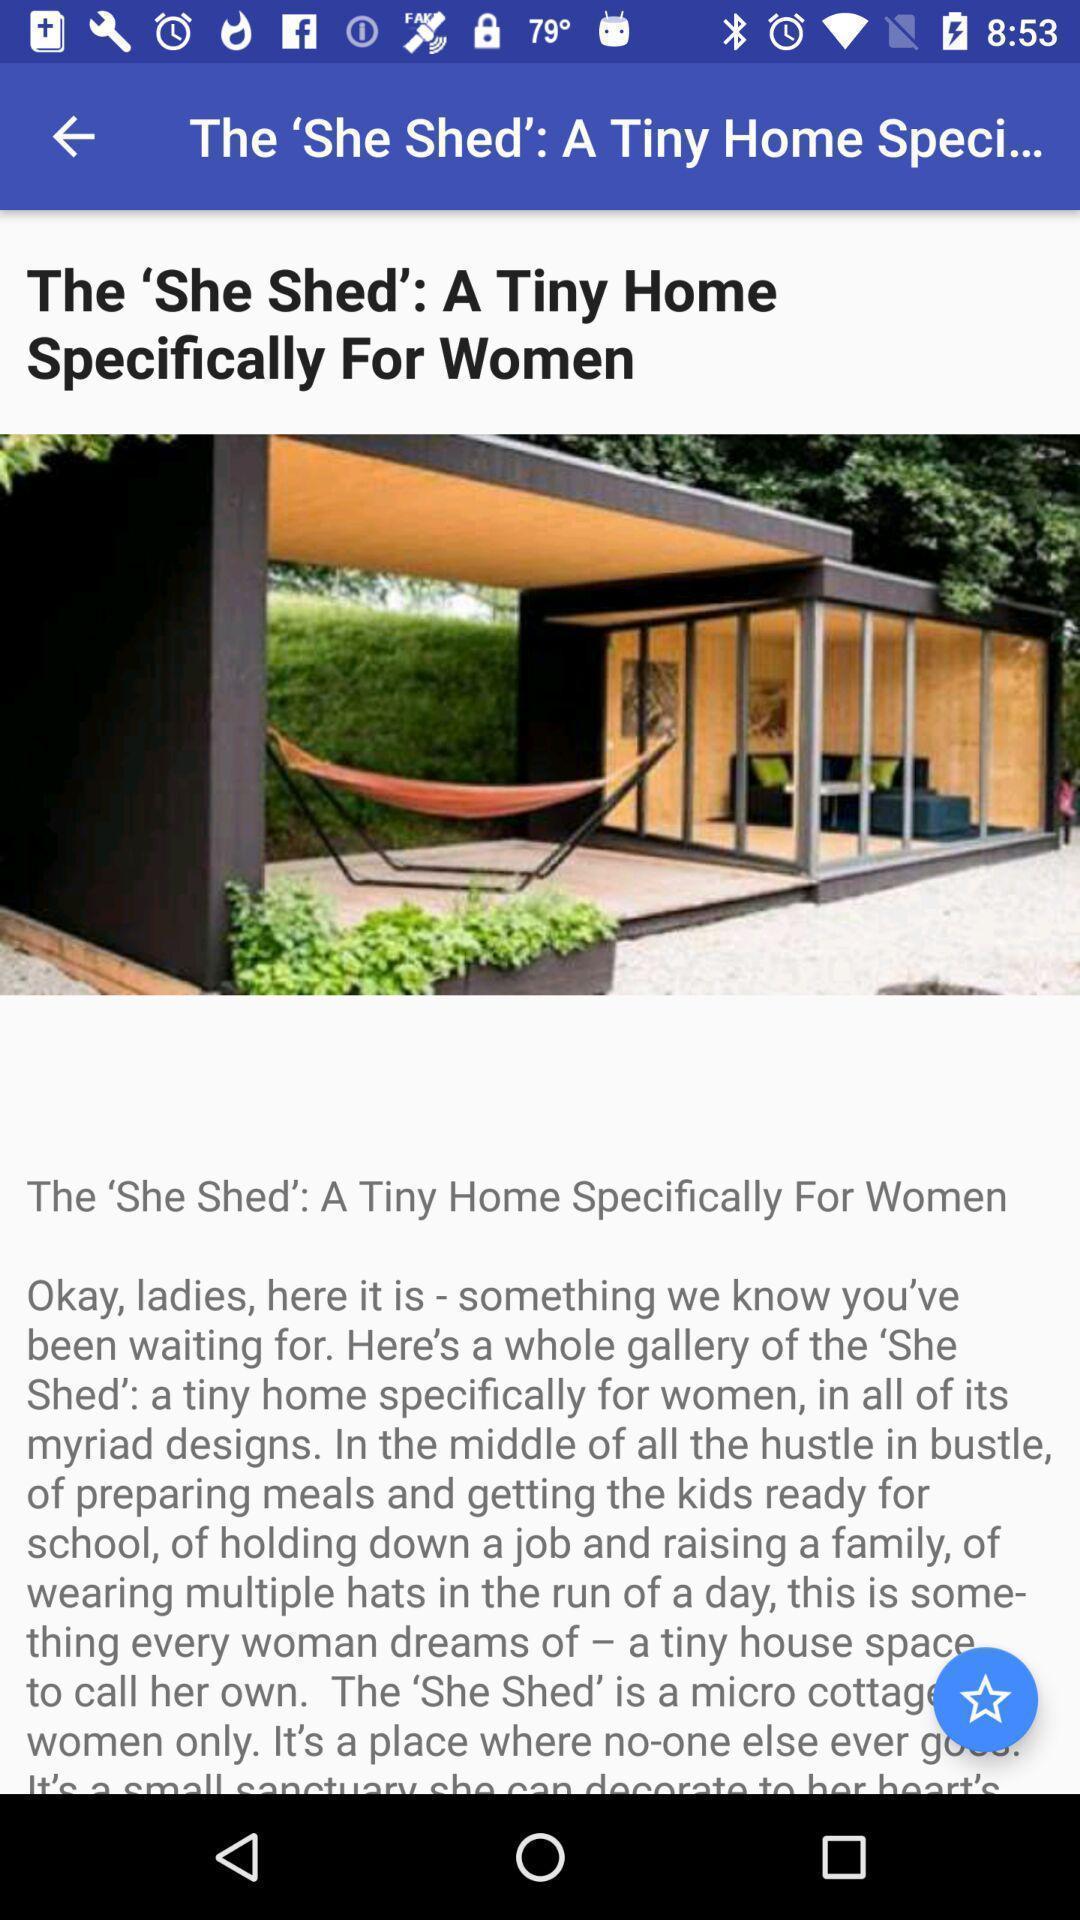Summarize the main components in this picture. Window displaying a app regarding home. 